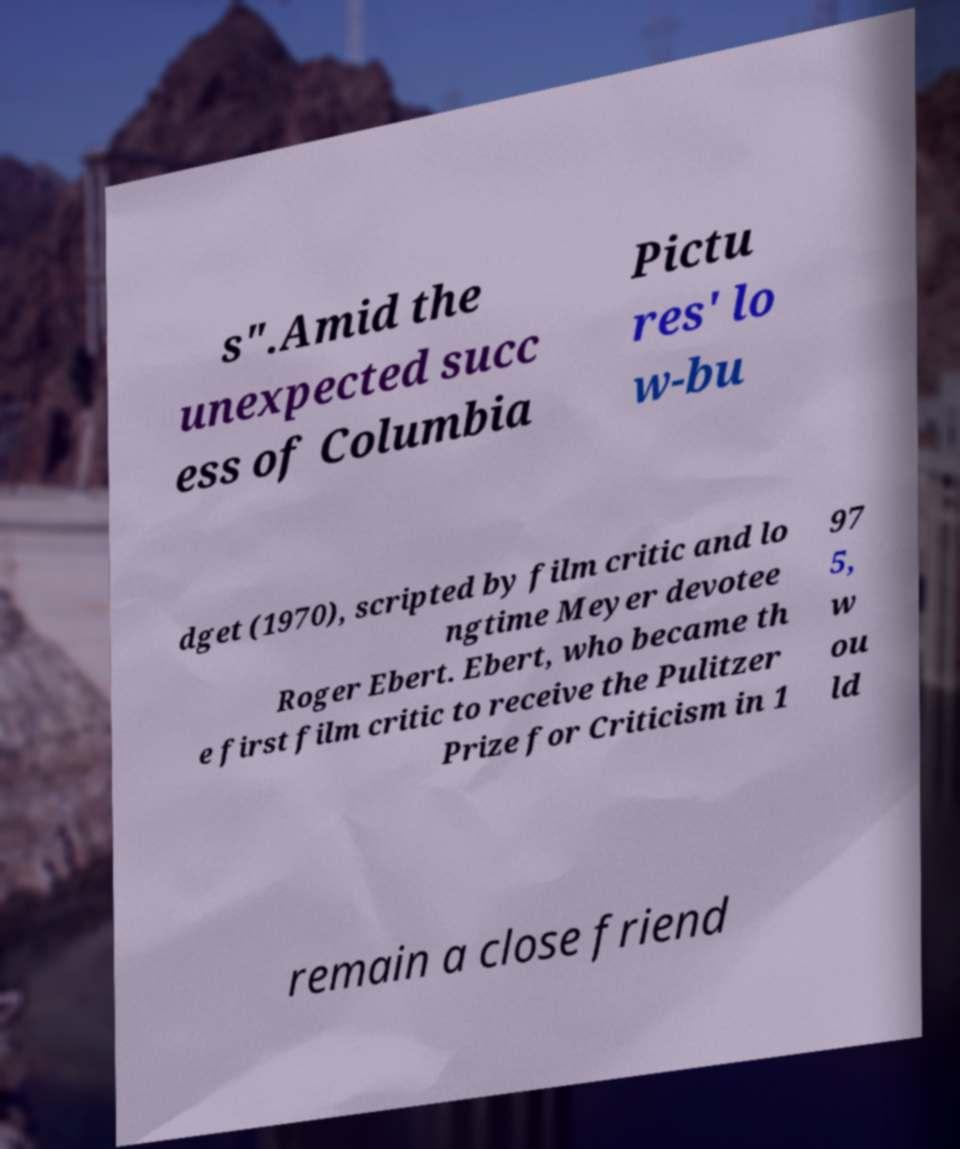Could you extract and type out the text from this image? s".Amid the unexpected succ ess of Columbia Pictu res' lo w-bu dget (1970), scripted by film critic and lo ngtime Meyer devotee Roger Ebert. Ebert, who became th e first film critic to receive the Pulitzer Prize for Criticism in 1 97 5, w ou ld remain a close friend 